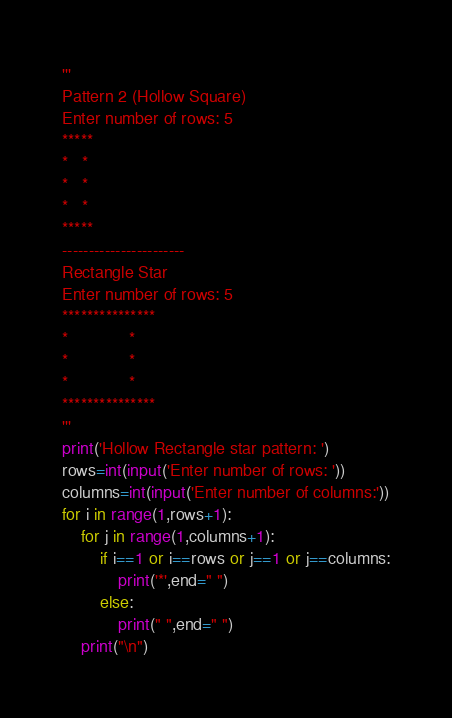Convert code to text. <code><loc_0><loc_0><loc_500><loc_500><_Python_>'''
Pattern 2 (Hollow Square)
Enter number of rows: 5
*****
*   *
*   *
*   *
*****
-----------------------
Rectangle Star
Enter number of rows: 5
***************
*             *
*             *
*             *
***************
'''
print('Hollow Rectangle star pattern: ')
rows=int(input('Enter number of rows: '))
columns=int(input('Enter number of columns:'))
for i in range(1,rows+1):
	for j in range(1,columns+1):
		if i==1 or i==rows or j==1 or j==columns:
			print('*',end=" ")
		else:
			print(" ",end=" ")
	print("\n")	</code> 